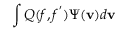Convert formula to latex. <formula><loc_0><loc_0><loc_500><loc_500>\int Q ( f , f ^ { ^ { \prime } } ) \Psi ( v ) d v</formula> 